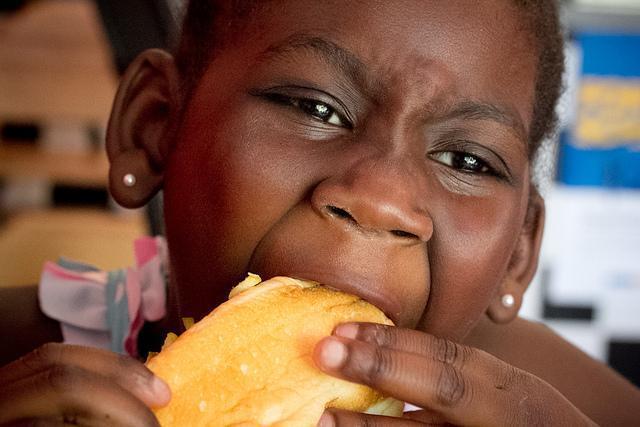Is the given caption "The person is touching the hot dog." fitting for the image?
Answer yes or no. Yes. 